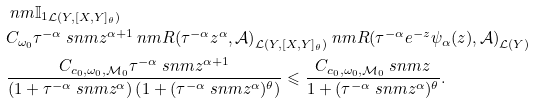<formula> <loc_0><loc_0><loc_500><loc_500>& \ n m { \mathbb { I } _ { 1 } } _ { \mathcal { L } ( Y , [ X , Y ] _ { \theta } ) } \\ & C _ { \omega _ { 0 } } \tau ^ { - \alpha } \ s n m { z } ^ { \alpha + 1 } \ n m { R ( \tau ^ { - \alpha } z ^ { \alpha } , \mathcal { A } ) } _ { \mathcal { L } ( Y , [ X , Y ] _ { \theta } ) } \ n m { R ( \tau ^ { - \alpha } e ^ { - z } \psi _ { \alpha } ( z ) , \mathcal { A } ) } _ { \mathcal { L } ( Y ) } \\ & \frac { C _ { c _ { 0 } , \omega _ { 0 } , \mathcal { M } _ { 0 } } \tau ^ { - \alpha } \ s n m { z } ^ { \alpha + 1 } } { \left ( 1 + \tau ^ { - \alpha } \ s n m { z } ^ { \alpha } \right ) \left ( 1 + ( \tau ^ { - \alpha } \ s n m { z } ^ { \alpha } ) ^ { \theta } \right ) } \leqslant \frac { C _ { c _ { 0 } , \omega _ { 0 } , \mathcal { M } _ { 0 } } \ s n m { z } } { 1 + ( \tau ^ { - \alpha } \ s n m { z } ^ { \alpha } ) ^ { \theta } } .</formula> 